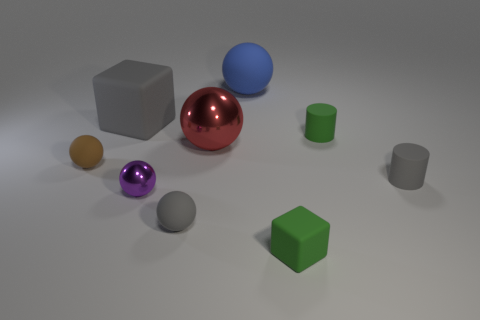In terms of lighting, where is the light source located in this scene based on the shadows? The light source appears to be coming from the top-left direction. This is indicated by the shadows being cast towards the bottom-right side of each object in the image. If all these objects had the same mass, which one would take more effort to roll? If they all had the same mass, the cube would require more effort to roll due to its shape. Unlike the spheres and cylinders, which roll smoothly, a cube has flat surfaces and edges that would make rolling an uneven and more effort-intensive action. 